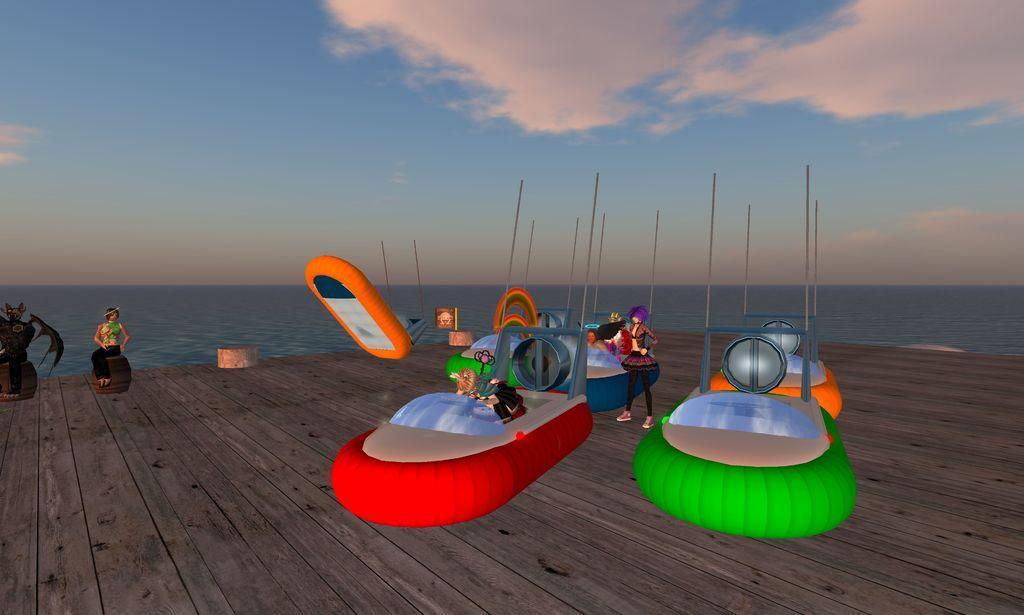Describe this image in one or two sentences. This is an animated image, we can see a few boats, poles, persons, and we can see the wooden floor, and we can see water, the sky with clouds. 